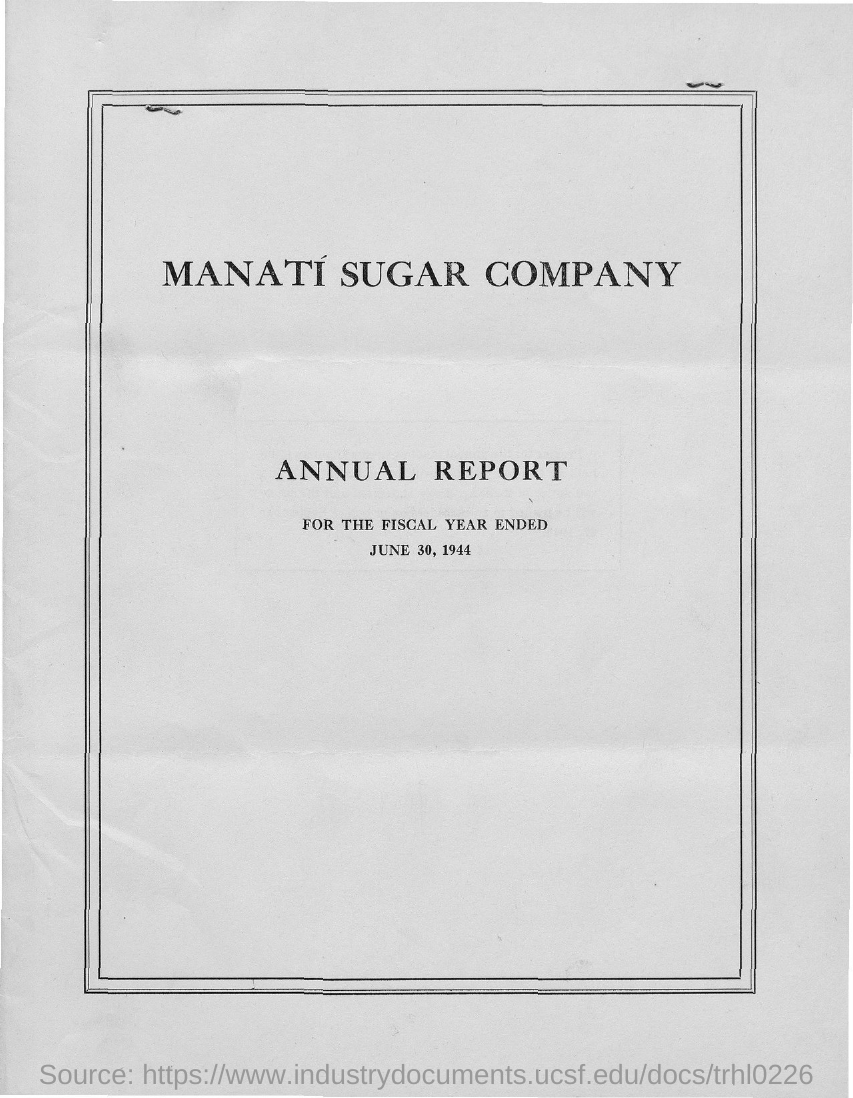Outline some significant characteristics in this image. The date mentioned in the document is June 30, 1944. The Manati Sugar Company is the name of the company. 